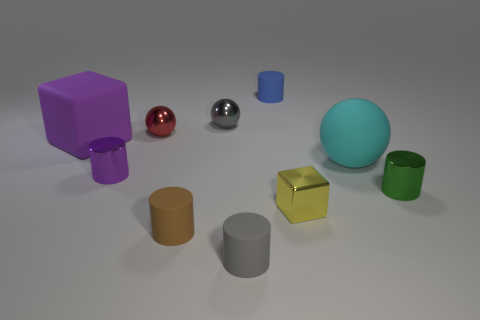What number of brown things have the same shape as the cyan object?
Give a very brief answer. 0. There is a cylinder that is the same color as the matte block; what material is it?
Ensure brevity in your answer.  Metal. Do the yellow object and the brown cylinder have the same material?
Offer a terse response. No. How many yellow blocks are in front of the big rubber object left of the matte cylinder behind the tiny green shiny cylinder?
Provide a short and direct response. 1. Is there a blue object that has the same material as the big cyan thing?
Your response must be concise. Yes. Are there fewer small objects than tiny green rubber balls?
Ensure brevity in your answer.  No. There is a cylinder that is on the left side of the brown thing; is it the same color as the matte cube?
Make the answer very short. Yes. There is a big object that is left of the tiny rubber cylinder behind the tiny metal cylinder left of the tiny green metal cylinder; what is its material?
Provide a short and direct response. Rubber. Is there a small cylinder of the same color as the rubber block?
Your response must be concise. Yes. Are there fewer purple cylinders behind the purple shiny cylinder than gray rubber blocks?
Offer a terse response. No. 